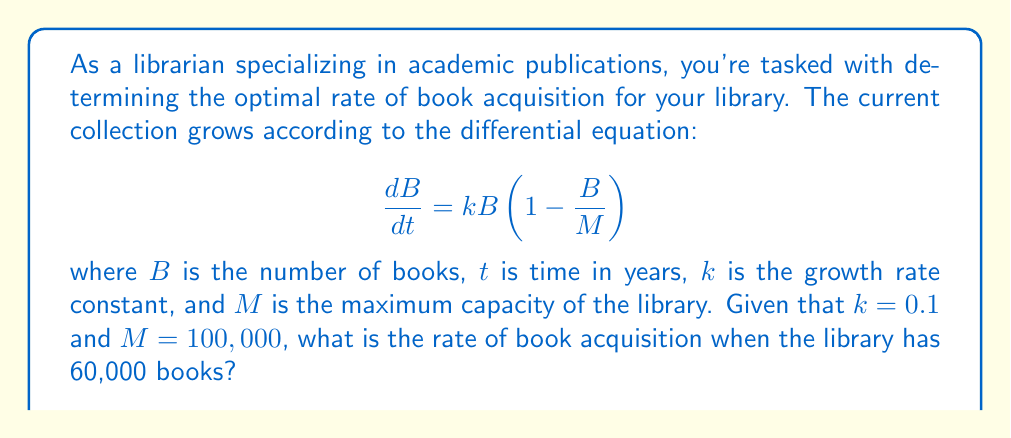Help me with this question. To solve this problem, we need to use the given differential equation and substitute the known values:

1. We're given:
   $k = 0.1$
   $M = 100,000$
   $B = 60,000$

2. The differential equation is:
   $$\frac{dB}{dt} = kB(1 - \frac{B}{M})$$

3. Substitute the known values:
   $$\frac{dB}{dt} = 0.1 \cdot 60,000 \cdot (1 - \frac{60,000}{100,000})$$

4. Simplify:
   $$\frac{dB}{dt} = 6,000 \cdot (1 - 0.6)$$
   $$\frac{dB}{dt} = 6,000 \cdot 0.4$$
   $$\frac{dB}{dt} = 2,400$$

5. The rate of book acquisition is $\frac{dB}{dt}$, which we've calculated to be 2,400 books per year.
Answer: The rate of book acquisition when the library has 60,000 books is 2,400 books per year. 